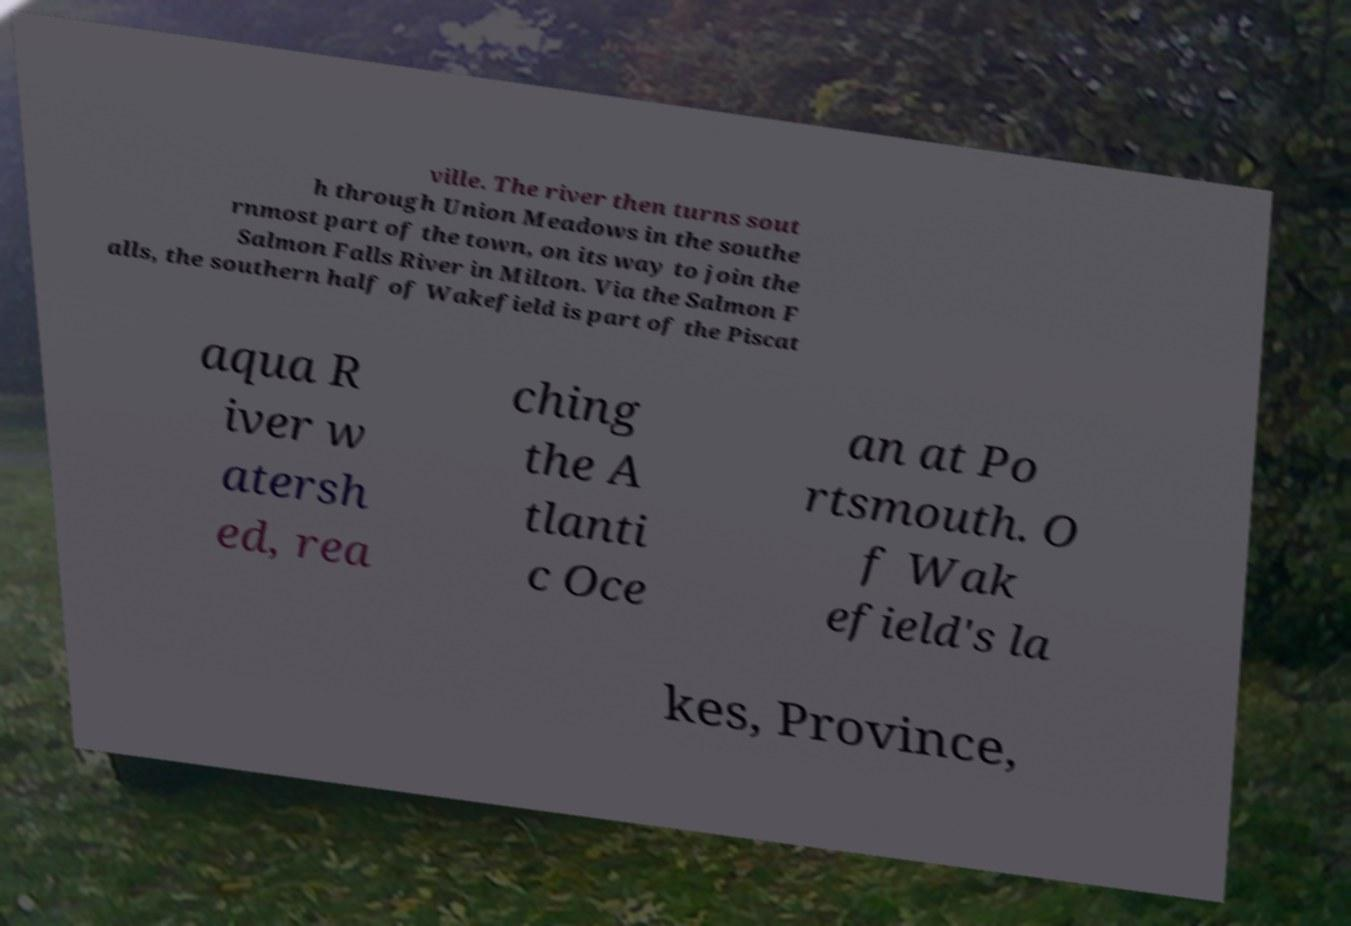Can you accurately transcribe the text from the provided image for me? ville. The river then turns sout h through Union Meadows in the southe rnmost part of the town, on its way to join the Salmon Falls River in Milton. Via the Salmon F alls, the southern half of Wakefield is part of the Piscat aqua R iver w atersh ed, rea ching the A tlanti c Oce an at Po rtsmouth. O f Wak efield's la kes, Province, 